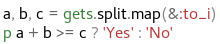<code> <loc_0><loc_0><loc_500><loc_500><_Ruby_>a, b, c = gets.split.map(&:to_i)
p a + b >= c ? 'Yes' : 'No'</code> 